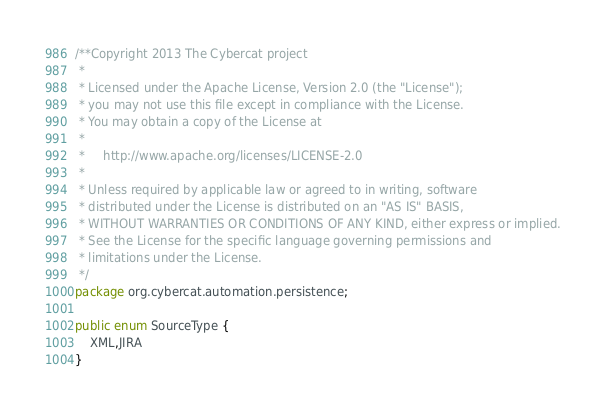Convert code to text. <code><loc_0><loc_0><loc_500><loc_500><_Java_>/**Copyright 2013 The Cybercat project
 * 
 * Licensed under the Apache License, Version 2.0 (the "License");
 * you may not use this file except in compliance with the License.
 * You may obtain a copy of the License at
 * 
 *     http://www.apache.org/licenses/LICENSE-2.0
 *     
 * Unless required by applicable law or agreed to in writing, software
 * distributed under the License is distributed on an "AS IS" BASIS,
 * WITHOUT WARRANTIES OR CONDITIONS OF ANY KIND, either express or implied.
 * See the License for the specific language governing permissions and
 * limitations under the License.
 */
package org.cybercat.automation.persistence;

public enum SourceType {
    XML,JIRA
}
</code> 